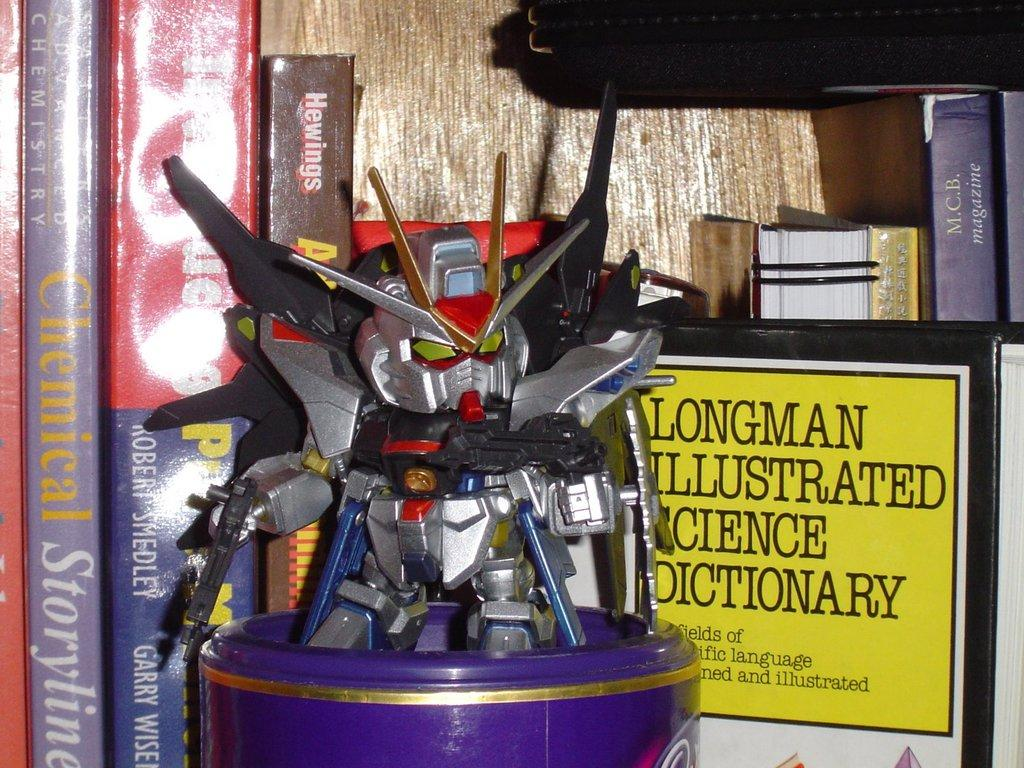What type of toy is in the image? There is a robot toy in the image. Where is the robot toy placed? The robot toy is on a box. What else can be seen in the image besides the robot toy? There are multiple books in the image. Where are the books located? The books are on a shelf. How many mice are hiding behind the books on the shelf? There are no mice present in the image; it only features a robot toy on a box and multiple books on a shelf. 